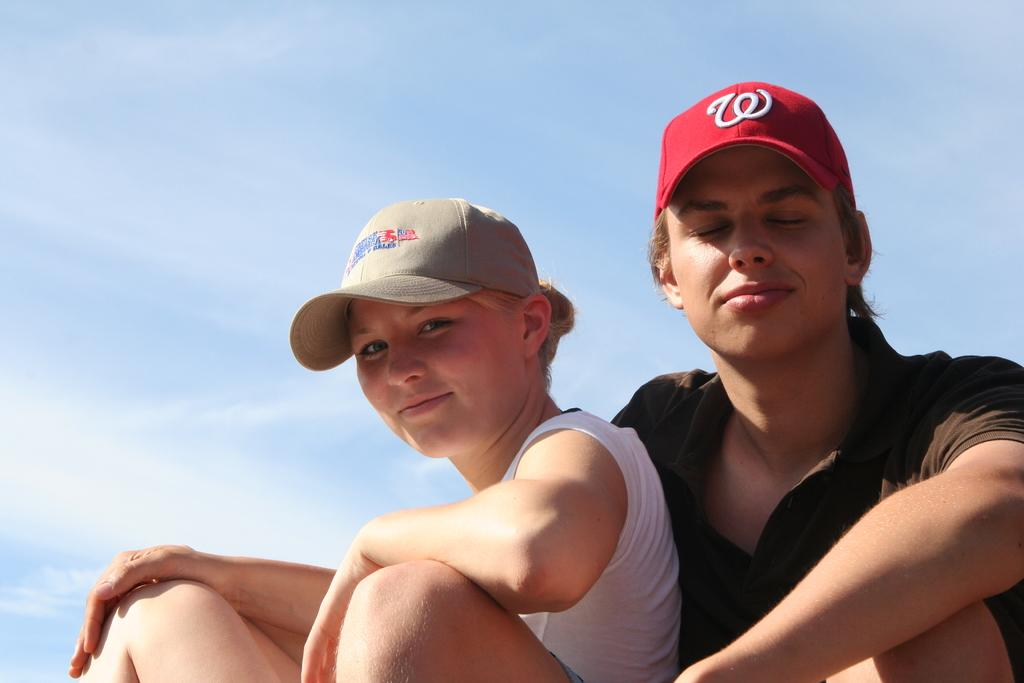How many people are in the image? There are two people in the image. What are the people wearing on their heads? The people are wearing caps. What colors are the dresses worn by the people? The people are wearing different color dresses. What can be seen in the background of the image? There are clouds and a blue sky in the background of the image. Are there any bears playing in a field in the image? No, there are no bears or fields present in the image. 